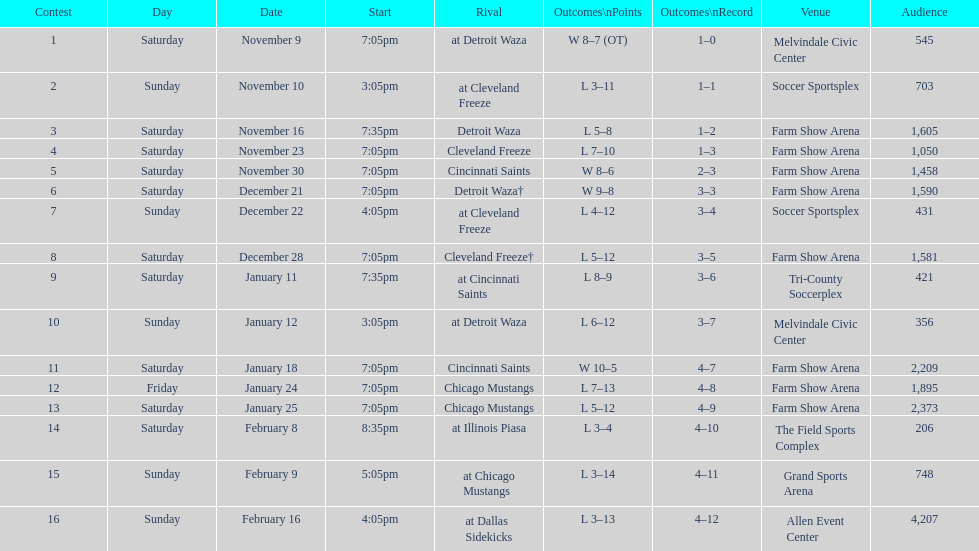How many games did the harrisburg heat win in which they scored eight or more goals? 4. 